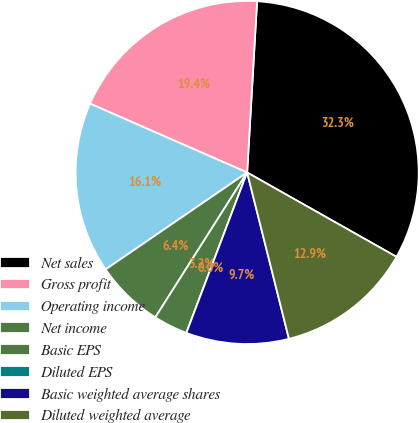Convert chart to OTSL. <chart><loc_0><loc_0><loc_500><loc_500><pie_chart><fcel>Net sales<fcel>Gross profit<fcel>Operating income<fcel>Net income<fcel>Basic EPS<fcel>Diluted EPS<fcel>Basic weighted average shares<fcel>Diluted weighted average<nl><fcel>32.26%<fcel>19.35%<fcel>16.13%<fcel>6.45%<fcel>3.23%<fcel>0.0%<fcel>9.68%<fcel>12.9%<nl></chart> 